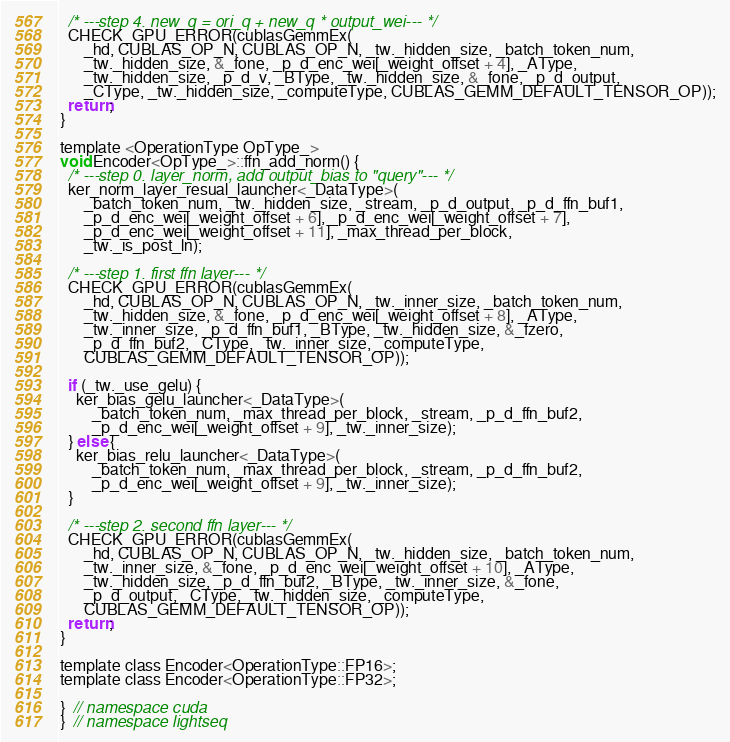<code> <loc_0><loc_0><loc_500><loc_500><_Cuda_>  /* ---step 4. new_q = ori_q + new_q * output_wei--- */
  CHECK_GPU_ERROR(cublasGemmEx(
      _hd, CUBLAS_OP_N, CUBLAS_OP_N, _tw._hidden_size, _batch_token_num,
      _tw._hidden_size, &_fone, _p_d_enc_wei[_weight_offset + 4], _AType,
      _tw._hidden_size, _p_d_v, _BType, _tw._hidden_size, &_fone, _p_d_output,
      _CType, _tw._hidden_size, _computeType, CUBLAS_GEMM_DEFAULT_TENSOR_OP));
  return;
}

template <OperationType OpType_>
void Encoder<OpType_>::ffn_add_norm() {
  /* ---step 0. layer_norm, add output_bias to "query"--- */
  ker_norm_layer_resual_launcher<_DataType>(
      _batch_token_num, _tw._hidden_size, _stream, _p_d_output, _p_d_ffn_buf1,
      _p_d_enc_wei[_weight_offset + 6], _p_d_enc_wei[_weight_offset + 7],
      _p_d_enc_wei[_weight_offset + 11], _max_thread_per_block,
      _tw._is_post_ln);

  /* ---step 1. first ffn layer--- */
  CHECK_GPU_ERROR(cublasGemmEx(
      _hd, CUBLAS_OP_N, CUBLAS_OP_N, _tw._inner_size, _batch_token_num,
      _tw._hidden_size, &_fone, _p_d_enc_wei[_weight_offset + 8], _AType,
      _tw._inner_size, _p_d_ffn_buf1, _BType, _tw._hidden_size, &_fzero,
      _p_d_ffn_buf2, _CType, _tw._inner_size, _computeType,
      CUBLAS_GEMM_DEFAULT_TENSOR_OP));

  if (_tw._use_gelu) {
    ker_bias_gelu_launcher<_DataType>(
        _batch_token_num, _max_thread_per_block, _stream, _p_d_ffn_buf2,
        _p_d_enc_wei[_weight_offset + 9], _tw._inner_size);
  } else {
    ker_bias_relu_launcher<_DataType>(
        _batch_token_num, _max_thread_per_block, _stream, _p_d_ffn_buf2,
        _p_d_enc_wei[_weight_offset + 9], _tw._inner_size);
  }

  /* ---step 2. second ffn layer--- */
  CHECK_GPU_ERROR(cublasGemmEx(
      _hd, CUBLAS_OP_N, CUBLAS_OP_N, _tw._hidden_size, _batch_token_num,
      _tw._inner_size, &_fone, _p_d_enc_wei[_weight_offset + 10], _AType,
      _tw._hidden_size, _p_d_ffn_buf2, _BType, _tw._inner_size, &_fone,
      _p_d_output, _CType, _tw._hidden_size, _computeType,
      CUBLAS_GEMM_DEFAULT_TENSOR_OP));
  return;
}

template class Encoder<OperationType::FP16>;
template class Encoder<OperationType::FP32>;

}  // namespace cuda
}  // namespace lightseq
</code> 